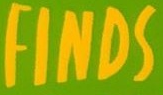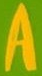Read the text content from these images in order, separated by a semicolon. FINDS; A 